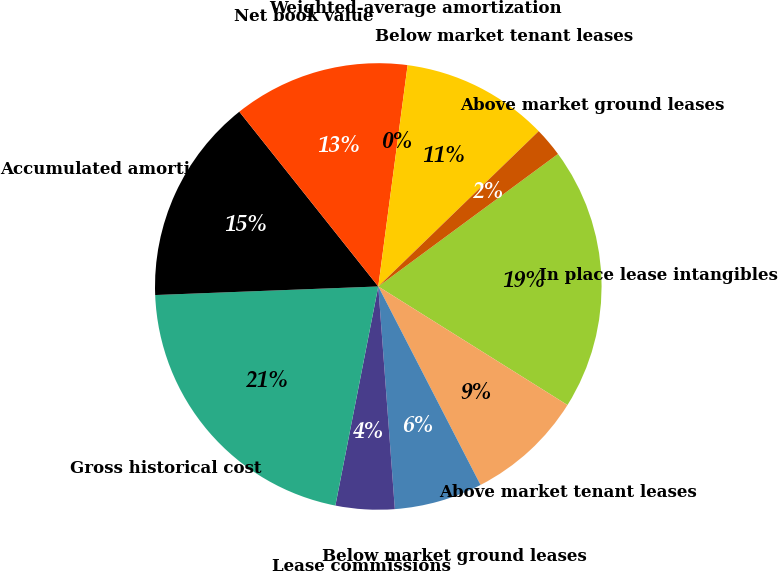Convert chart to OTSL. <chart><loc_0><loc_0><loc_500><loc_500><pie_chart><fcel>In place lease intangibles<fcel>Above market tenant leases<fcel>Below market ground leases<fcel>Lease commissions<fcel>Gross historical cost<fcel>Accumulated amortization<fcel>Net book value<fcel>Weighted-average amortization<fcel>Below market tenant leases<fcel>Above market ground leases<nl><fcel>19.02%<fcel>8.52%<fcel>6.39%<fcel>4.26%<fcel>21.31%<fcel>14.92%<fcel>12.79%<fcel>0.0%<fcel>10.66%<fcel>2.13%<nl></chart> 